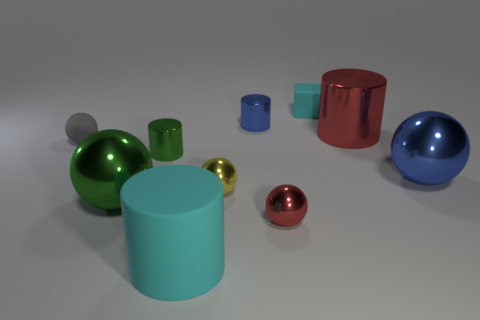Subtract all metallic cylinders. How many cylinders are left? 1 Subtract 2 cylinders. How many cylinders are left? 2 Subtract all gray spheres. How many spheres are left? 4 Subtract all red spheres. Subtract all cyan blocks. How many spheres are left? 4 Subtract 1 green balls. How many objects are left? 9 Subtract all blocks. How many objects are left? 9 Subtract all big balls. Subtract all rubber objects. How many objects are left? 5 Add 6 red metal cylinders. How many red metal cylinders are left? 7 Add 8 brown balls. How many brown balls exist? 8 